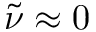<formula> <loc_0><loc_0><loc_500><loc_500>\tilde { \nu } \approx 0</formula> 